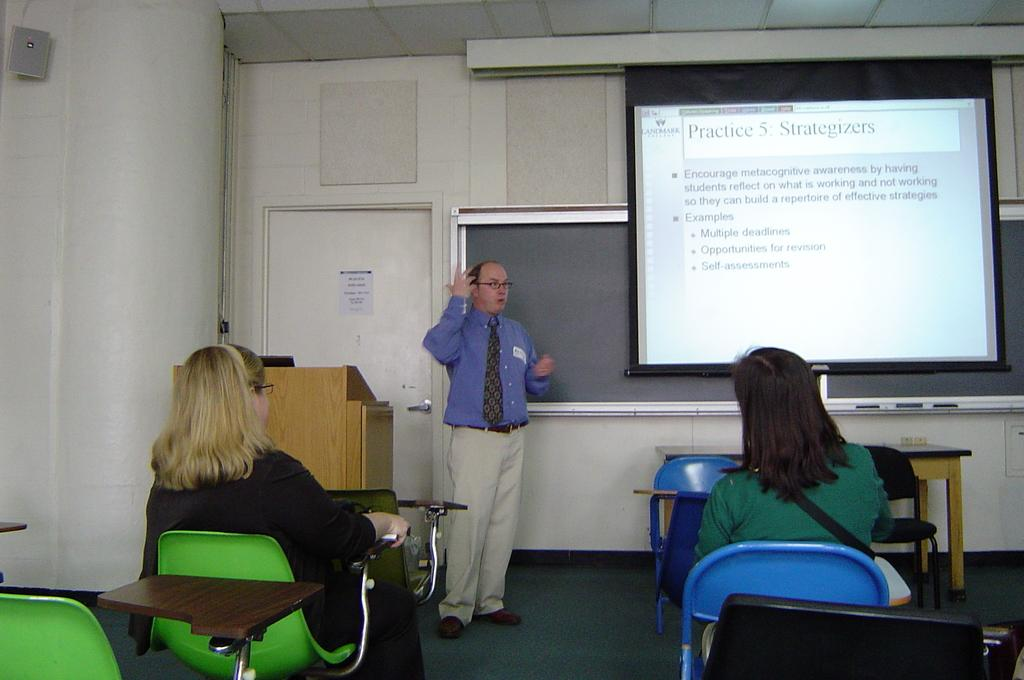How many people are sitting in chairs in the image? There are two ladies sitting in chairs in the image. What is the person in the image doing? There is a person standing and speaking in the image. What can be seen behind the ladies and the person? There is a projected image behind the ladies and the person. What is the temperature outside during the summer in the image? The provided facts do not mention any information about the temperature or the season, so it cannot be determined from the image. 